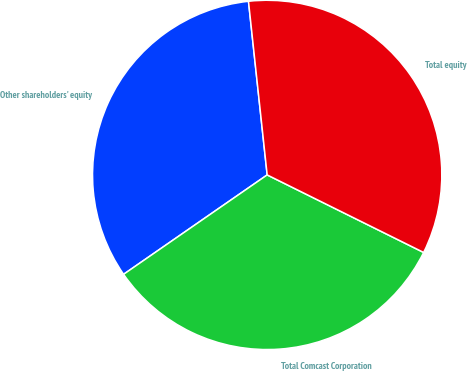<chart> <loc_0><loc_0><loc_500><loc_500><pie_chart><fcel>Other shareholders' equity<fcel>Total Comcast Corporation<fcel>Total equity<nl><fcel>32.93%<fcel>33.04%<fcel>34.03%<nl></chart> 